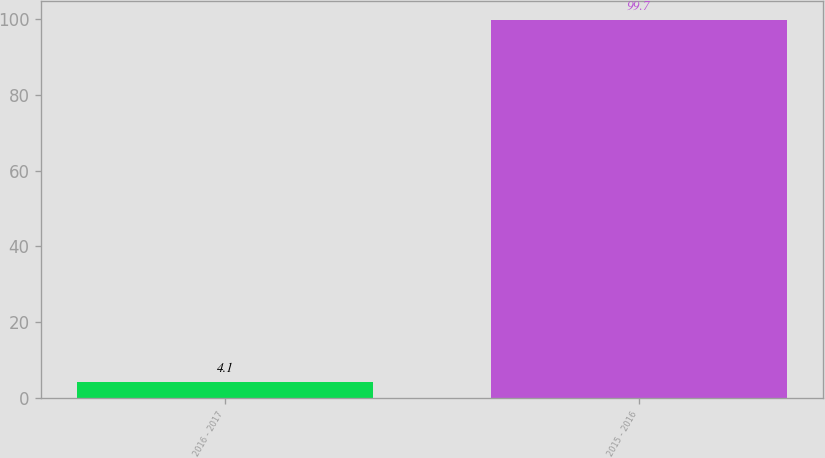Convert chart. <chart><loc_0><loc_0><loc_500><loc_500><bar_chart><fcel>2016 - 2017<fcel>2015 - 2016<nl><fcel>4.1<fcel>99.7<nl></chart> 